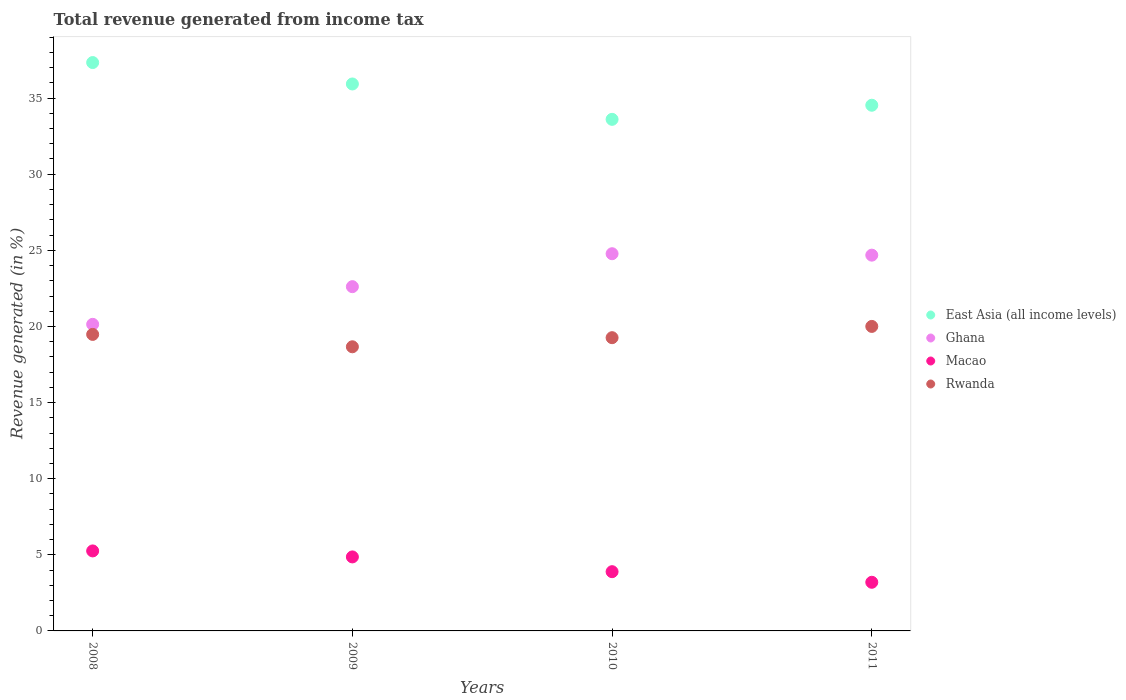Is the number of dotlines equal to the number of legend labels?
Give a very brief answer. Yes. What is the total revenue generated in Ghana in 2009?
Make the answer very short. 22.61. Across all years, what is the maximum total revenue generated in Macao?
Your response must be concise. 5.25. Across all years, what is the minimum total revenue generated in Macao?
Your answer should be compact. 3.2. In which year was the total revenue generated in Rwanda minimum?
Offer a terse response. 2009. What is the total total revenue generated in East Asia (all income levels) in the graph?
Ensure brevity in your answer.  141.4. What is the difference between the total revenue generated in East Asia (all income levels) in 2008 and that in 2010?
Your answer should be compact. 3.73. What is the difference between the total revenue generated in Rwanda in 2011 and the total revenue generated in Ghana in 2010?
Make the answer very short. -4.78. What is the average total revenue generated in Ghana per year?
Give a very brief answer. 23.05. In the year 2010, what is the difference between the total revenue generated in East Asia (all income levels) and total revenue generated in Ghana?
Keep it short and to the point. 8.83. What is the ratio of the total revenue generated in Ghana in 2008 to that in 2011?
Your response must be concise. 0.82. Is the total revenue generated in Macao in 2010 less than that in 2011?
Offer a terse response. No. What is the difference between the highest and the second highest total revenue generated in East Asia (all income levels)?
Your response must be concise. 1.41. What is the difference between the highest and the lowest total revenue generated in Macao?
Provide a succinct answer. 2.06. In how many years, is the total revenue generated in Ghana greater than the average total revenue generated in Ghana taken over all years?
Provide a succinct answer. 2. Is the sum of the total revenue generated in Macao in 2009 and 2011 greater than the maximum total revenue generated in Ghana across all years?
Provide a succinct answer. No. Is it the case that in every year, the sum of the total revenue generated in Ghana and total revenue generated in East Asia (all income levels)  is greater than the sum of total revenue generated in Rwanda and total revenue generated in Macao?
Your answer should be very brief. Yes. Does the total revenue generated in East Asia (all income levels) monotonically increase over the years?
Make the answer very short. No. Is the total revenue generated in Rwanda strictly less than the total revenue generated in Ghana over the years?
Your response must be concise. Yes. How many years are there in the graph?
Offer a very short reply. 4. What is the difference between two consecutive major ticks on the Y-axis?
Ensure brevity in your answer.  5. Does the graph contain any zero values?
Make the answer very short. No. What is the title of the graph?
Provide a short and direct response. Total revenue generated from income tax. What is the label or title of the Y-axis?
Keep it short and to the point. Revenue generated (in %). What is the Revenue generated (in %) in East Asia (all income levels) in 2008?
Your answer should be compact. 37.33. What is the Revenue generated (in %) of Ghana in 2008?
Give a very brief answer. 20.14. What is the Revenue generated (in %) of Macao in 2008?
Provide a short and direct response. 5.25. What is the Revenue generated (in %) of Rwanda in 2008?
Offer a very short reply. 19.48. What is the Revenue generated (in %) in East Asia (all income levels) in 2009?
Provide a succinct answer. 35.93. What is the Revenue generated (in %) of Ghana in 2009?
Provide a succinct answer. 22.61. What is the Revenue generated (in %) in Macao in 2009?
Your response must be concise. 4.86. What is the Revenue generated (in %) in Rwanda in 2009?
Keep it short and to the point. 18.66. What is the Revenue generated (in %) of East Asia (all income levels) in 2010?
Your answer should be compact. 33.6. What is the Revenue generated (in %) in Ghana in 2010?
Your response must be concise. 24.78. What is the Revenue generated (in %) in Macao in 2010?
Make the answer very short. 3.89. What is the Revenue generated (in %) of Rwanda in 2010?
Offer a terse response. 19.26. What is the Revenue generated (in %) in East Asia (all income levels) in 2011?
Your answer should be compact. 34.53. What is the Revenue generated (in %) of Ghana in 2011?
Offer a terse response. 24.68. What is the Revenue generated (in %) of Macao in 2011?
Your response must be concise. 3.2. What is the Revenue generated (in %) of Rwanda in 2011?
Your answer should be very brief. 20. Across all years, what is the maximum Revenue generated (in %) in East Asia (all income levels)?
Ensure brevity in your answer.  37.33. Across all years, what is the maximum Revenue generated (in %) of Ghana?
Make the answer very short. 24.78. Across all years, what is the maximum Revenue generated (in %) in Macao?
Make the answer very short. 5.25. Across all years, what is the maximum Revenue generated (in %) in Rwanda?
Give a very brief answer. 20. Across all years, what is the minimum Revenue generated (in %) in East Asia (all income levels)?
Provide a succinct answer. 33.6. Across all years, what is the minimum Revenue generated (in %) of Ghana?
Your answer should be compact. 20.14. Across all years, what is the minimum Revenue generated (in %) of Macao?
Provide a succinct answer. 3.2. Across all years, what is the minimum Revenue generated (in %) in Rwanda?
Your answer should be compact. 18.66. What is the total Revenue generated (in %) in East Asia (all income levels) in the graph?
Your response must be concise. 141.4. What is the total Revenue generated (in %) of Ghana in the graph?
Give a very brief answer. 92.21. What is the total Revenue generated (in %) in Macao in the graph?
Provide a short and direct response. 17.2. What is the total Revenue generated (in %) in Rwanda in the graph?
Offer a terse response. 77.41. What is the difference between the Revenue generated (in %) of East Asia (all income levels) in 2008 and that in 2009?
Ensure brevity in your answer.  1.41. What is the difference between the Revenue generated (in %) in Ghana in 2008 and that in 2009?
Provide a succinct answer. -2.47. What is the difference between the Revenue generated (in %) in Macao in 2008 and that in 2009?
Provide a short and direct response. 0.39. What is the difference between the Revenue generated (in %) of Rwanda in 2008 and that in 2009?
Provide a succinct answer. 0.81. What is the difference between the Revenue generated (in %) of East Asia (all income levels) in 2008 and that in 2010?
Give a very brief answer. 3.73. What is the difference between the Revenue generated (in %) in Ghana in 2008 and that in 2010?
Offer a very short reply. -4.64. What is the difference between the Revenue generated (in %) of Macao in 2008 and that in 2010?
Keep it short and to the point. 1.36. What is the difference between the Revenue generated (in %) in Rwanda in 2008 and that in 2010?
Your answer should be compact. 0.22. What is the difference between the Revenue generated (in %) of East Asia (all income levels) in 2008 and that in 2011?
Your response must be concise. 2.8. What is the difference between the Revenue generated (in %) of Ghana in 2008 and that in 2011?
Provide a short and direct response. -4.54. What is the difference between the Revenue generated (in %) of Macao in 2008 and that in 2011?
Keep it short and to the point. 2.06. What is the difference between the Revenue generated (in %) in Rwanda in 2008 and that in 2011?
Make the answer very short. -0.52. What is the difference between the Revenue generated (in %) of East Asia (all income levels) in 2009 and that in 2010?
Ensure brevity in your answer.  2.32. What is the difference between the Revenue generated (in %) of Ghana in 2009 and that in 2010?
Ensure brevity in your answer.  -2.16. What is the difference between the Revenue generated (in %) in Macao in 2009 and that in 2010?
Offer a terse response. 0.97. What is the difference between the Revenue generated (in %) in Rwanda in 2009 and that in 2010?
Keep it short and to the point. -0.6. What is the difference between the Revenue generated (in %) in East Asia (all income levels) in 2009 and that in 2011?
Make the answer very short. 1.4. What is the difference between the Revenue generated (in %) in Ghana in 2009 and that in 2011?
Your answer should be very brief. -2.07. What is the difference between the Revenue generated (in %) of Macao in 2009 and that in 2011?
Keep it short and to the point. 1.67. What is the difference between the Revenue generated (in %) of Rwanda in 2009 and that in 2011?
Ensure brevity in your answer.  -1.34. What is the difference between the Revenue generated (in %) of East Asia (all income levels) in 2010 and that in 2011?
Provide a short and direct response. -0.93. What is the difference between the Revenue generated (in %) in Ghana in 2010 and that in 2011?
Ensure brevity in your answer.  0.09. What is the difference between the Revenue generated (in %) of Macao in 2010 and that in 2011?
Your answer should be compact. 0.7. What is the difference between the Revenue generated (in %) of Rwanda in 2010 and that in 2011?
Your answer should be very brief. -0.74. What is the difference between the Revenue generated (in %) of East Asia (all income levels) in 2008 and the Revenue generated (in %) of Ghana in 2009?
Provide a succinct answer. 14.72. What is the difference between the Revenue generated (in %) of East Asia (all income levels) in 2008 and the Revenue generated (in %) of Macao in 2009?
Your response must be concise. 32.47. What is the difference between the Revenue generated (in %) in East Asia (all income levels) in 2008 and the Revenue generated (in %) in Rwanda in 2009?
Provide a short and direct response. 18.67. What is the difference between the Revenue generated (in %) of Ghana in 2008 and the Revenue generated (in %) of Macao in 2009?
Offer a terse response. 15.28. What is the difference between the Revenue generated (in %) in Ghana in 2008 and the Revenue generated (in %) in Rwanda in 2009?
Provide a succinct answer. 1.47. What is the difference between the Revenue generated (in %) in Macao in 2008 and the Revenue generated (in %) in Rwanda in 2009?
Keep it short and to the point. -13.41. What is the difference between the Revenue generated (in %) in East Asia (all income levels) in 2008 and the Revenue generated (in %) in Ghana in 2010?
Ensure brevity in your answer.  12.56. What is the difference between the Revenue generated (in %) of East Asia (all income levels) in 2008 and the Revenue generated (in %) of Macao in 2010?
Keep it short and to the point. 33.44. What is the difference between the Revenue generated (in %) of East Asia (all income levels) in 2008 and the Revenue generated (in %) of Rwanda in 2010?
Provide a succinct answer. 18.07. What is the difference between the Revenue generated (in %) in Ghana in 2008 and the Revenue generated (in %) in Macao in 2010?
Provide a short and direct response. 16.25. What is the difference between the Revenue generated (in %) in Ghana in 2008 and the Revenue generated (in %) in Rwanda in 2010?
Your answer should be very brief. 0.88. What is the difference between the Revenue generated (in %) in Macao in 2008 and the Revenue generated (in %) in Rwanda in 2010?
Keep it short and to the point. -14.01. What is the difference between the Revenue generated (in %) in East Asia (all income levels) in 2008 and the Revenue generated (in %) in Ghana in 2011?
Keep it short and to the point. 12.65. What is the difference between the Revenue generated (in %) in East Asia (all income levels) in 2008 and the Revenue generated (in %) in Macao in 2011?
Ensure brevity in your answer.  34.14. What is the difference between the Revenue generated (in %) of East Asia (all income levels) in 2008 and the Revenue generated (in %) of Rwanda in 2011?
Ensure brevity in your answer.  17.33. What is the difference between the Revenue generated (in %) of Ghana in 2008 and the Revenue generated (in %) of Macao in 2011?
Give a very brief answer. 16.94. What is the difference between the Revenue generated (in %) in Ghana in 2008 and the Revenue generated (in %) in Rwanda in 2011?
Provide a succinct answer. 0.14. What is the difference between the Revenue generated (in %) of Macao in 2008 and the Revenue generated (in %) of Rwanda in 2011?
Offer a very short reply. -14.75. What is the difference between the Revenue generated (in %) of East Asia (all income levels) in 2009 and the Revenue generated (in %) of Ghana in 2010?
Offer a terse response. 11.15. What is the difference between the Revenue generated (in %) of East Asia (all income levels) in 2009 and the Revenue generated (in %) of Macao in 2010?
Your response must be concise. 32.04. What is the difference between the Revenue generated (in %) of East Asia (all income levels) in 2009 and the Revenue generated (in %) of Rwanda in 2010?
Your response must be concise. 16.67. What is the difference between the Revenue generated (in %) of Ghana in 2009 and the Revenue generated (in %) of Macao in 2010?
Offer a very short reply. 18.72. What is the difference between the Revenue generated (in %) of Ghana in 2009 and the Revenue generated (in %) of Rwanda in 2010?
Make the answer very short. 3.35. What is the difference between the Revenue generated (in %) of Macao in 2009 and the Revenue generated (in %) of Rwanda in 2010?
Provide a short and direct response. -14.4. What is the difference between the Revenue generated (in %) of East Asia (all income levels) in 2009 and the Revenue generated (in %) of Ghana in 2011?
Ensure brevity in your answer.  11.24. What is the difference between the Revenue generated (in %) in East Asia (all income levels) in 2009 and the Revenue generated (in %) in Macao in 2011?
Offer a terse response. 32.73. What is the difference between the Revenue generated (in %) in East Asia (all income levels) in 2009 and the Revenue generated (in %) in Rwanda in 2011?
Your answer should be very brief. 15.93. What is the difference between the Revenue generated (in %) in Ghana in 2009 and the Revenue generated (in %) in Macao in 2011?
Your answer should be compact. 19.42. What is the difference between the Revenue generated (in %) of Ghana in 2009 and the Revenue generated (in %) of Rwanda in 2011?
Your response must be concise. 2.61. What is the difference between the Revenue generated (in %) of Macao in 2009 and the Revenue generated (in %) of Rwanda in 2011?
Keep it short and to the point. -15.14. What is the difference between the Revenue generated (in %) in East Asia (all income levels) in 2010 and the Revenue generated (in %) in Ghana in 2011?
Provide a succinct answer. 8.92. What is the difference between the Revenue generated (in %) in East Asia (all income levels) in 2010 and the Revenue generated (in %) in Macao in 2011?
Make the answer very short. 30.41. What is the difference between the Revenue generated (in %) in East Asia (all income levels) in 2010 and the Revenue generated (in %) in Rwanda in 2011?
Ensure brevity in your answer.  13.6. What is the difference between the Revenue generated (in %) of Ghana in 2010 and the Revenue generated (in %) of Macao in 2011?
Provide a short and direct response. 21.58. What is the difference between the Revenue generated (in %) in Ghana in 2010 and the Revenue generated (in %) in Rwanda in 2011?
Keep it short and to the point. 4.78. What is the difference between the Revenue generated (in %) of Macao in 2010 and the Revenue generated (in %) of Rwanda in 2011?
Ensure brevity in your answer.  -16.11. What is the average Revenue generated (in %) in East Asia (all income levels) per year?
Keep it short and to the point. 35.35. What is the average Revenue generated (in %) of Ghana per year?
Ensure brevity in your answer.  23.05. What is the average Revenue generated (in %) in Macao per year?
Ensure brevity in your answer.  4.3. What is the average Revenue generated (in %) in Rwanda per year?
Provide a short and direct response. 19.35. In the year 2008, what is the difference between the Revenue generated (in %) in East Asia (all income levels) and Revenue generated (in %) in Ghana?
Keep it short and to the point. 17.19. In the year 2008, what is the difference between the Revenue generated (in %) in East Asia (all income levels) and Revenue generated (in %) in Macao?
Your answer should be compact. 32.08. In the year 2008, what is the difference between the Revenue generated (in %) of East Asia (all income levels) and Revenue generated (in %) of Rwanda?
Give a very brief answer. 17.86. In the year 2008, what is the difference between the Revenue generated (in %) of Ghana and Revenue generated (in %) of Macao?
Your answer should be compact. 14.88. In the year 2008, what is the difference between the Revenue generated (in %) in Ghana and Revenue generated (in %) in Rwanda?
Your response must be concise. 0.66. In the year 2008, what is the difference between the Revenue generated (in %) of Macao and Revenue generated (in %) of Rwanda?
Offer a very short reply. -14.22. In the year 2009, what is the difference between the Revenue generated (in %) in East Asia (all income levels) and Revenue generated (in %) in Ghana?
Your answer should be compact. 13.31. In the year 2009, what is the difference between the Revenue generated (in %) in East Asia (all income levels) and Revenue generated (in %) in Macao?
Provide a succinct answer. 31.07. In the year 2009, what is the difference between the Revenue generated (in %) in East Asia (all income levels) and Revenue generated (in %) in Rwanda?
Make the answer very short. 17.26. In the year 2009, what is the difference between the Revenue generated (in %) of Ghana and Revenue generated (in %) of Macao?
Keep it short and to the point. 17.75. In the year 2009, what is the difference between the Revenue generated (in %) of Ghana and Revenue generated (in %) of Rwanda?
Offer a terse response. 3.95. In the year 2009, what is the difference between the Revenue generated (in %) in Macao and Revenue generated (in %) in Rwanda?
Your answer should be very brief. -13.8. In the year 2010, what is the difference between the Revenue generated (in %) of East Asia (all income levels) and Revenue generated (in %) of Ghana?
Make the answer very short. 8.83. In the year 2010, what is the difference between the Revenue generated (in %) in East Asia (all income levels) and Revenue generated (in %) in Macao?
Provide a short and direct response. 29.71. In the year 2010, what is the difference between the Revenue generated (in %) in East Asia (all income levels) and Revenue generated (in %) in Rwanda?
Provide a short and direct response. 14.34. In the year 2010, what is the difference between the Revenue generated (in %) of Ghana and Revenue generated (in %) of Macao?
Make the answer very short. 20.89. In the year 2010, what is the difference between the Revenue generated (in %) of Ghana and Revenue generated (in %) of Rwanda?
Keep it short and to the point. 5.52. In the year 2010, what is the difference between the Revenue generated (in %) in Macao and Revenue generated (in %) in Rwanda?
Offer a very short reply. -15.37. In the year 2011, what is the difference between the Revenue generated (in %) in East Asia (all income levels) and Revenue generated (in %) in Ghana?
Make the answer very short. 9.85. In the year 2011, what is the difference between the Revenue generated (in %) in East Asia (all income levels) and Revenue generated (in %) in Macao?
Provide a succinct answer. 31.34. In the year 2011, what is the difference between the Revenue generated (in %) in East Asia (all income levels) and Revenue generated (in %) in Rwanda?
Keep it short and to the point. 14.53. In the year 2011, what is the difference between the Revenue generated (in %) in Ghana and Revenue generated (in %) in Macao?
Offer a terse response. 21.49. In the year 2011, what is the difference between the Revenue generated (in %) in Ghana and Revenue generated (in %) in Rwanda?
Provide a succinct answer. 4.68. In the year 2011, what is the difference between the Revenue generated (in %) of Macao and Revenue generated (in %) of Rwanda?
Your response must be concise. -16.81. What is the ratio of the Revenue generated (in %) of East Asia (all income levels) in 2008 to that in 2009?
Make the answer very short. 1.04. What is the ratio of the Revenue generated (in %) of Ghana in 2008 to that in 2009?
Ensure brevity in your answer.  0.89. What is the ratio of the Revenue generated (in %) in Macao in 2008 to that in 2009?
Keep it short and to the point. 1.08. What is the ratio of the Revenue generated (in %) in Rwanda in 2008 to that in 2009?
Your answer should be very brief. 1.04. What is the ratio of the Revenue generated (in %) in East Asia (all income levels) in 2008 to that in 2010?
Provide a short and direct response. 1.11. What is the ratio of the Revenue generated (in %) of Ghana in 2008 to that in 2010?
Your answer should be compact. 0.81. What is the ratio of the Revenue generated (in %) of Macao in 2008 to that in 2010?
Ensure brevity in your answer.  1.35. What is the ratio of the Revenue generated (in %) in Rwanda in 2008 to that in 2010?
Give a very brief answer. 1.01. What is the ratio of the Revenue generated (in %) of East Asia (all income levels) in 2008 to that in 2011?
Your response must be concise. 1.08. What is the ratio of the Revenue generated (in %) of Ghana in 2008 to that in 2011?
Provide a short and direct response. 0.82. What is the ratio of the Revenue generated (in %) in Macao in 2008 to that in 2011?
Provide a succinct answer. 1.64. What is the ratio of the Revenue generated (in %) in Rwanda in 2008 to that in 2011?
Make the answer very short. 0.97. What is the ratio of the Revenue generated (in %) of East Asia (all income levels) in 2009 to that in 2010?
Your answer should be very brief. 1.07. What is the ratio of the Revenue generated (in %) in Ghana in 2009 to that in 2010?
Make the answer very short. 0.91. What is the ratio of the Revenue generated (in %) in Macao in 2009 to that in 2010?
Provide a short and direct response. 1.25. What is the ratio of the Revenue generated (in %) in Rwanda in 2009 to that in 2010?
Your answer should be compact. 0.97. What is the ratio of the Revenue generated (in %) in East Asia (all income levels) in 2009 to that in 2011?
Provide a short and direct response. 1.04. What is the ratio of the Revenue generated (in %) of Ghana in 2009 to that in 2011?
Ensure brevity in your answer.  0.92. What is the ratio of the Revenue generated (in %) in Macao in 2009 to that in 2011?
Keep it short and to the point. 1.52. What is the ratio of the Revenue generated (in %) of Rwanda in 2009 to that in 2011?
Your response must be concise. 0.93. What is the ratio of the Revenue generated (in %) in East Asia (all income levels) in 2010 to that in 2011?
Offer a very short reply. 0.97. What is the ratio of the Revenue generated (in %) of Macao in 2010 to that in 2011?
Keep it short and to the point. 1.22. What is the difference between the highest and the second highest Revenue generated (in %) in East Asia (all income levels)?
Your answer should be compact. 1.41. What is the difference between the highest and the second highest Revenue generated (in %) of Ghana?
Your answer should be compact. 0.09. What is the difference between the highest and the second highest Revenue generated (in %) of Macao?
Ensure brevity in your answer.  0.39. What is the difference between the highest and the second highest Revenue generated (in %) in Rwanda?
Provide a short and direct response. 0.52. What is the difference between the highest and the lowest Revenue generated (in %) in East Asia (all income levels)?
Offer a terse response. 3.73. What is the difference between the highest and the lowest Revenue generated (in %) in Ghana?
Keep it short and to the point. 4.64. What is the difference between the highest and the lowest Revenue generated (in %) of Macao?
Your answer should be compact. 2.06. What is the difference between the highest and the lowest Revenue generated (in %) of Rwanda?
Your answer should be compact. 1.34. 